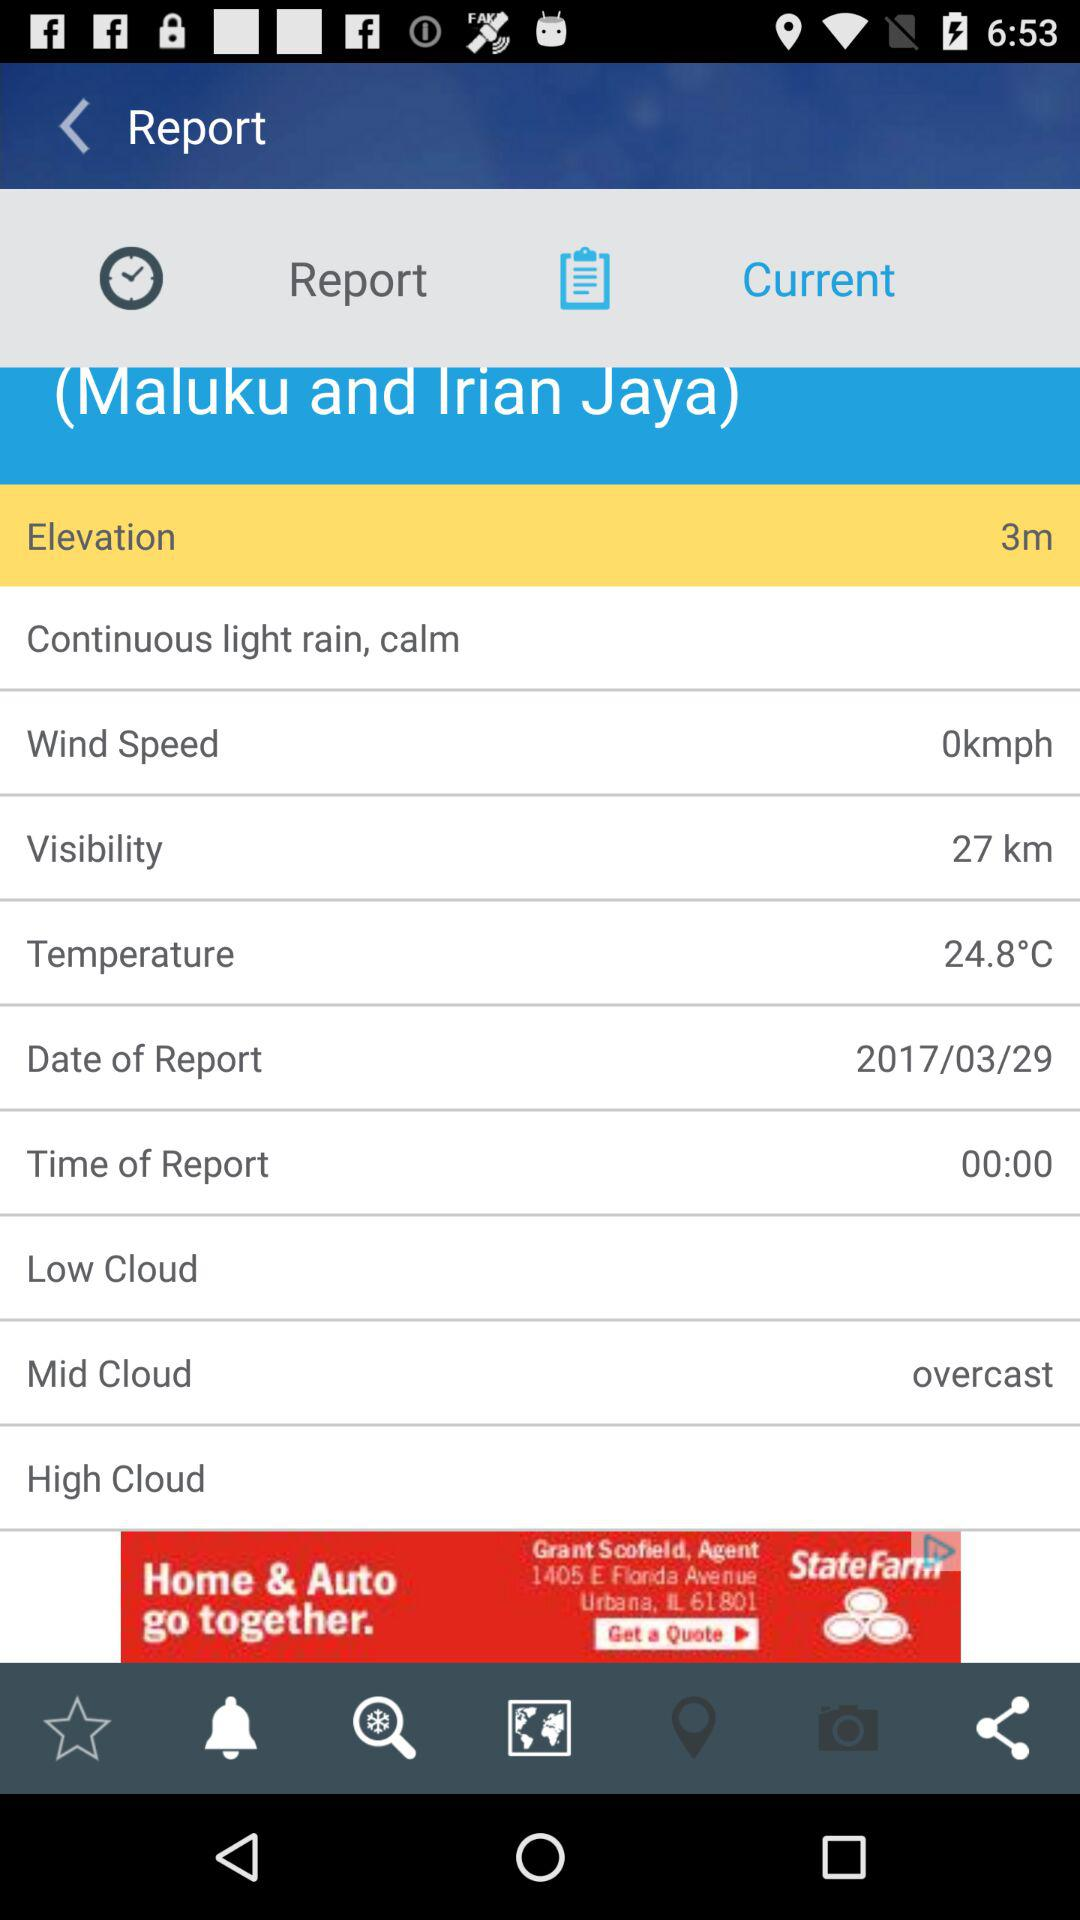How much is the elevation? The elevation is 3 m. 